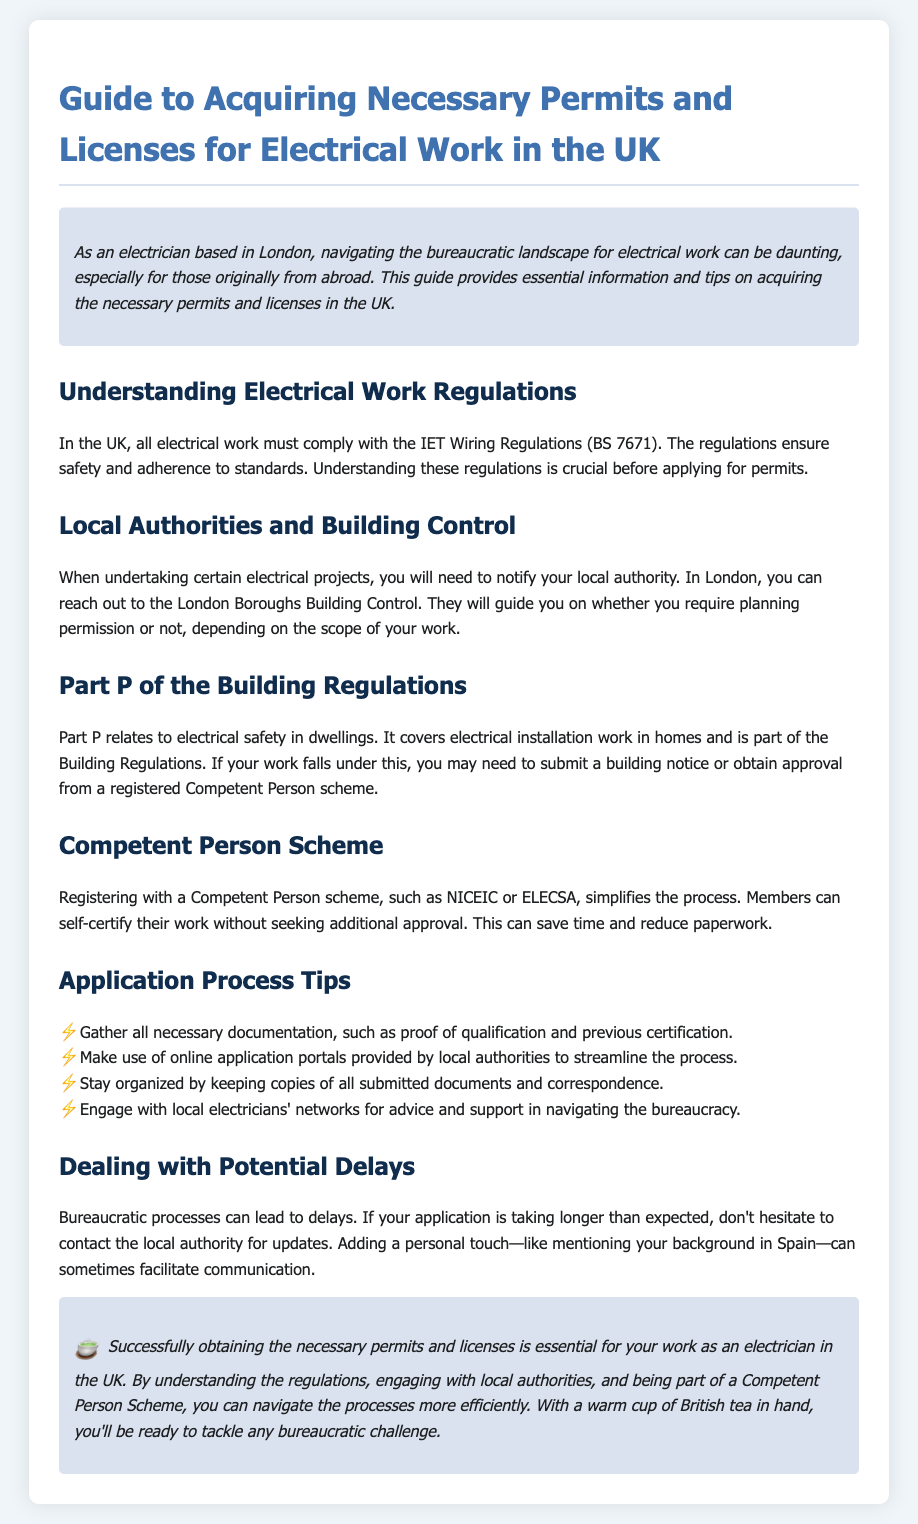What are the IET Wiring Regulations? The IET Wiring Regulations (BS 7671) ensure safety and adherence to standards for electrical work in the UK.
Answer: IET Wiring Regulations (BS 7671) Which authorities must be notified for electrical projects in London? You need to notify your local authority, specifically the London Boroughs Building Control.
Answer: London Boroughs Building Control What does Part P of the Building Regulations cover? Part P relates to electrical safety in dwellings and covers electrical installation work in homes.
Answer: Electrical safety in dwellings Name one Competent Person scheme mentioned in the document. The document mentions NICEIC or ELECSA as Competent Person schemes.
Answer: NICEIC or ELECSA What is a tip for the application process? A tip includes gathering all necessary documentation, such as proof of qualification and previous certification.
Answer: Gather all necessary documentation What should you do if your application takes longer than expected? If your application is delayed, contact the local authority for updates.
Answer: Contact the local authority What is the purpose of a Competent Person scheme? It simplifies the process by allowing members to self-certify their work without seeking additional approval.
Answer: Self-certify work What can help in navigating the bureaucracy according to the document? Engaging with local electricians' networks for advice and support can help.
Answer: Local electricians' networks What is the ambiance suggested for dealing with bureaucratic challenges? The conclusion suggests having a warm cup of British tea while tackling challenges.
Answer: Warm cup of British tea 